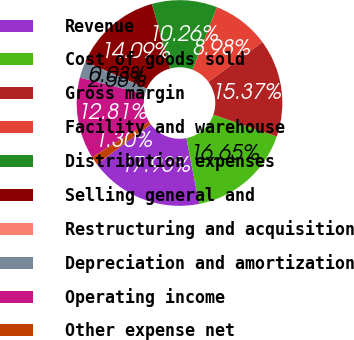Convert chart. <chart><loc_0><loc_0><loc_500><loc_500><pie_chart><fcel>Revenue<fcel>Cost of goods sold<fcel>Gross margin<fcel>Facility and warehouse<fcel>Distribution expenses<fcel>Selling general and<fcel>Restructuring and acquisition<fcel>Depreciation and amortization<fcel>Operating income<fcel>Other expense net<nl><fcel>17.93%<fcel>16.65%<fcel>15.37%<fcel>8.98%<fcel>10.26%<fcel>14.09%<fcel>0.03%<fcel>2.58%<fcel>12.81%<fcel>1.3%<nl></chart> 